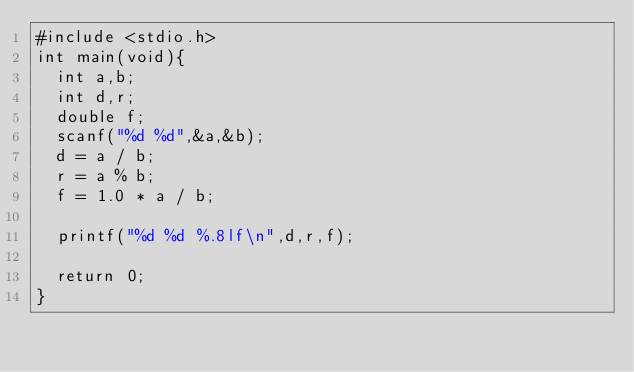Convert code to text. <code><loc_0><loc_0><loc_500><loc_500><_C_>#include <stdio.h>
int main(void){
	int a,b;
	int d,r;
	double f;
	scanf("%d %d",&a,&b);
	d = a / b;
	r = a % b;
	f = 1.0 * a / b;
	
	printf("%d %d %.8lf\n",d,r,f);
	
	return 0;
}
</code> 